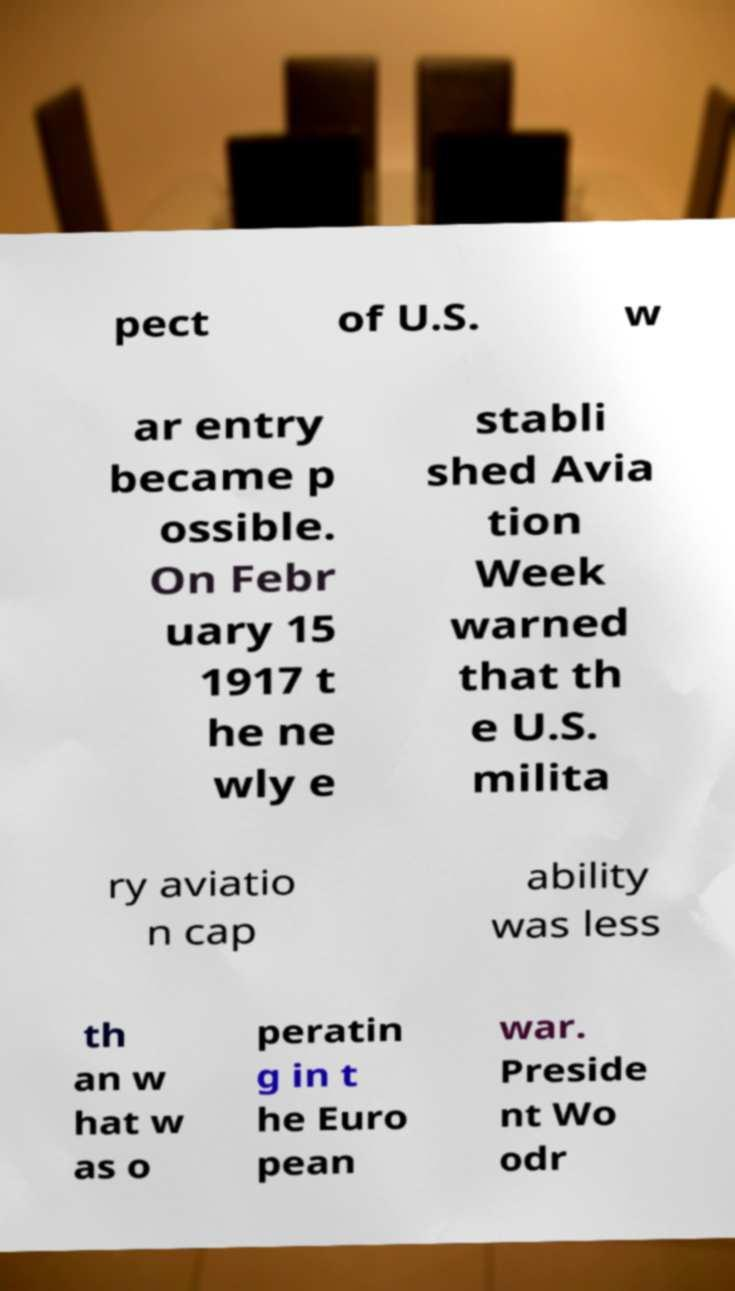For documentation purposes, I need the text within this image transcribed. Could you provide that? pect of U.S. w ar entry became p ossible. On Febr uary 15 1917 t he ne wly e stabli shed Avia tion Week warned that th e U.S. milita ry aviatio n cap ability was less th an w hat w as o peratin g in t he Euro pean war. Preside nt Wo odr 